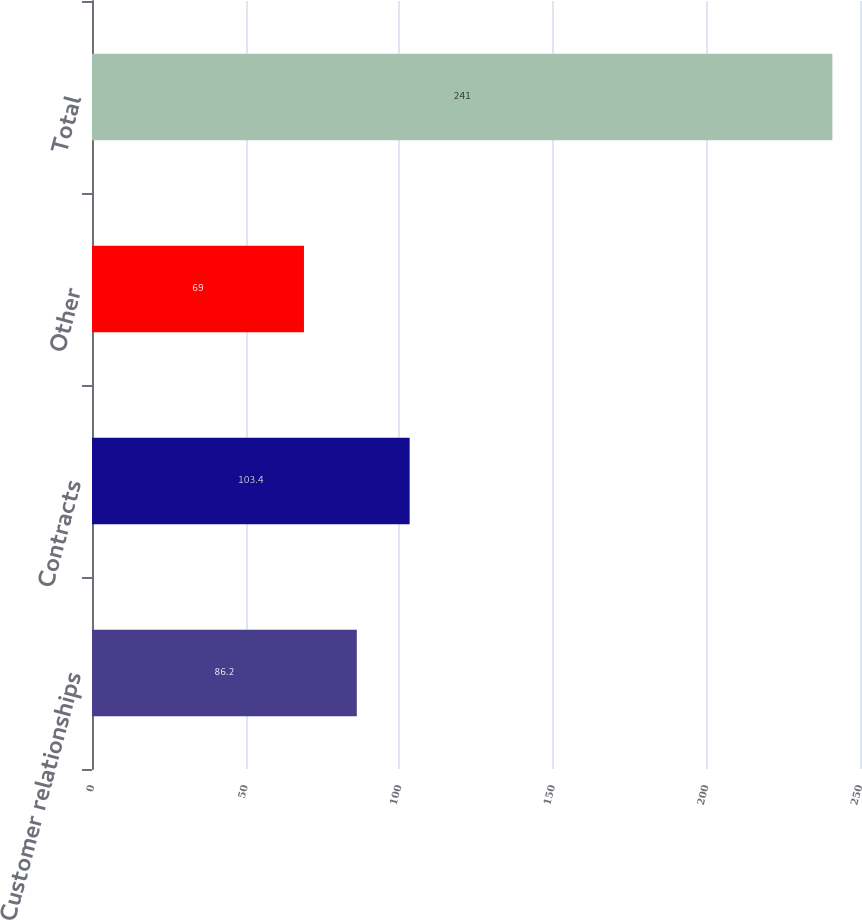<chart> <loc_0><loc_0><loc_500><loc_500><bar_chart><fcel>Customer relationships<fcel>Contracts<fcel>Other<fcel>Total<nl><fcel>86.2<fcel>103.4<fcel>69<fcel>241<nl></chart> 